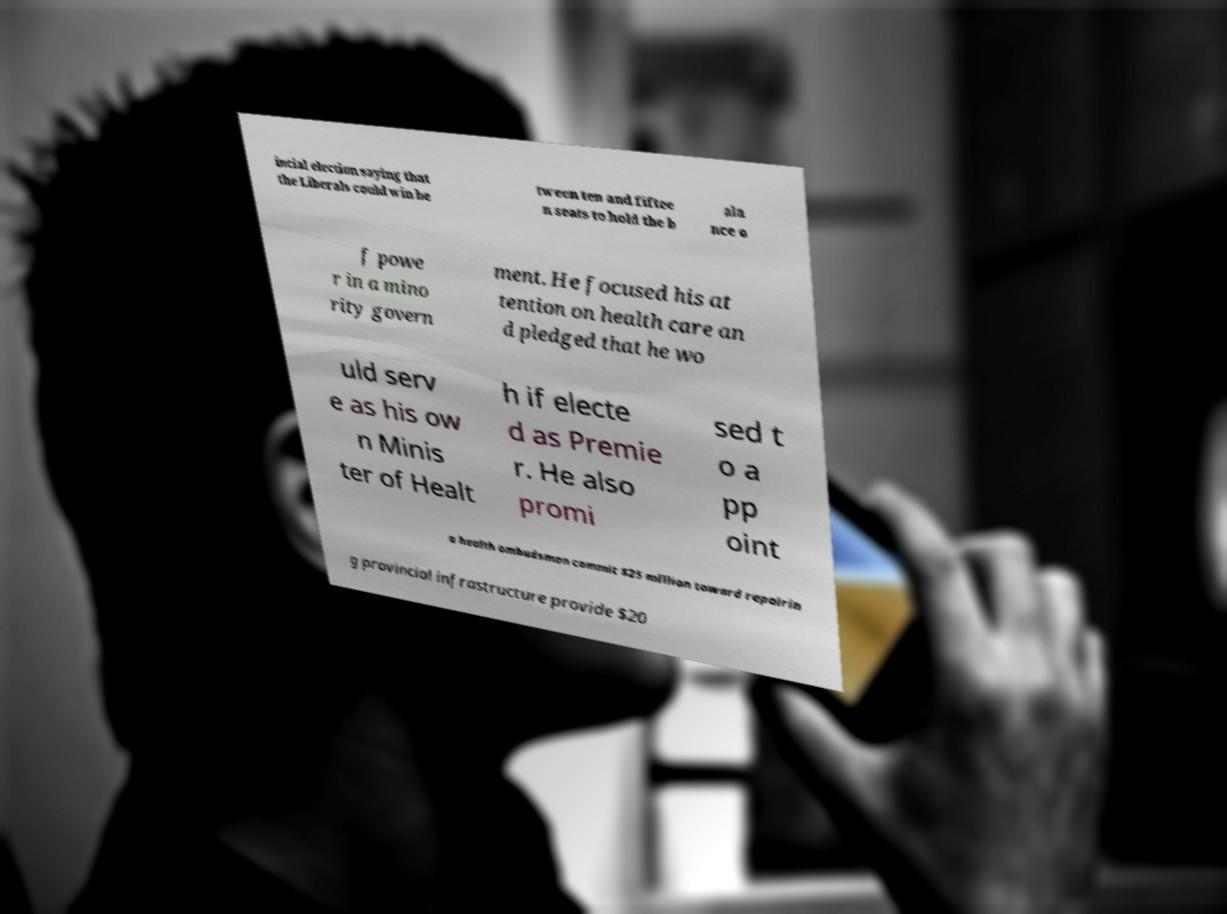What messages or text are displayed in this image? I need them in a readable, typed format. incial election saying that the Liberals could win be tween ten and fiftee n seats to hold the b ala nce o f powe r in a mino rity govern ment. He focused his at tention on health care an d pledged that he wo uld serv e as his ow n Minis ter of Healt h if electe d as Premie r. He also promi sed t o a pp oint a health ombudsman commit $25 million toward repairin g provincial infrastructure provide $20 